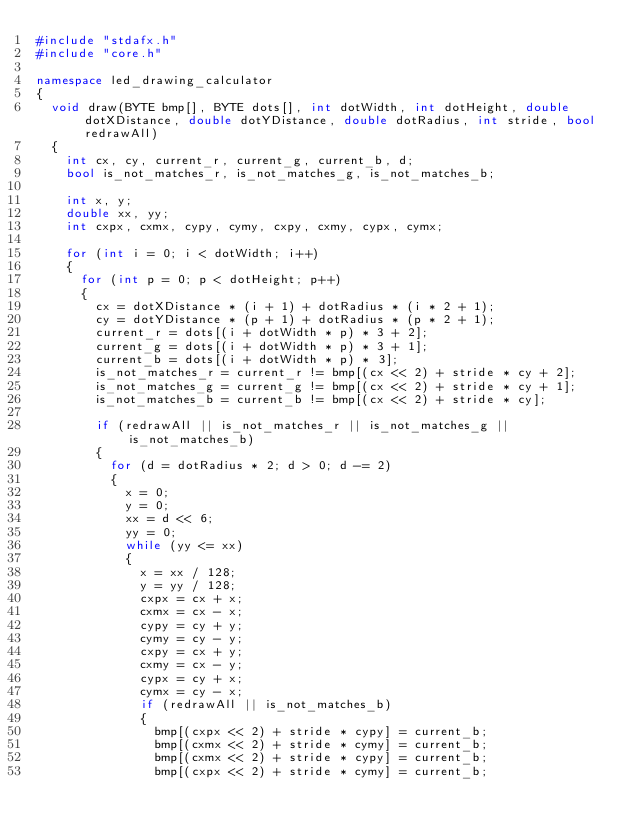<code> <loc_0><loc_0><loc_500><loc_500><_C++_>#include "stdafx.h"
#include "core.h"

namespace led_drawing_calculator
{
	void draw(BYTE bmp[], BYTE dots[], int dotWidth, int dotHeight, double dotXDistance, double dotYDistance, double dotRadius, int stride, bool redrawAll)
	{
		int cx, cy, current_r, current_g, current_b, d;
		bool is_not_matches_r, is_not_matches_g, is_not_matches_b;

		int x, y;
		double xx, yy;
		int cxpx, cxmx, cypy, cymy, cxpy, cxmy, cypx, cymx;

		for (int i = 0; i < dotWidth; i++)
		{
			for (int p = 0; p < dotHeight; p++)
			{
				cx = dotXDistance * (i + 1) + dotRadius * (i * 2 + 1);
				cy = dotYDistance * (p + 1) + dotRadius * (p * 2 + 1);
				current_r = dots[(i + dotWidth * p) * 3 + 2];
				current_g = dots[(i + dotWidth * p) * 3 + 1];
				current_b = dots[(i + dotWidth * p) * 3];
				is_not_matches_r = current_r != bmp[(cx << 2) + stride * cy + 2];
				is_not_matches_g = current_g != bmp[(cx << 2) + stride * cy + 1];
				is_not_matches_b = current_b != bmp[(cx << 2) + stride * cy];

				if (redrawAll || is_not_matches_r || is_not_matches_g || is_not_matches_b)
				{
					for (d = dotRadius * 2; d > 0; d -= 2)
					{
						x = 0;
						y = 0;
						xx = d << 6;
						yy = 0;
						while (yy <= xx)
						{
							x = xx / 128;
							y = yy / 128;
							cxpx = cx + x;
							cxmx = cx - x;
							cypy = cy + y;
							cymy = cy - y;
							cxpy = cx + y;
							cxmy = cx - y;
							cypx = cy + x;
							cymx = cy - x;
							if (redrawAll || is_not_matches_b)
							{
								bmp[(cxpx << 2) + stride * cypy] = current_b;
								bmp[(cxmx << 2) + stride * cymy] = current_b;
								bmp[(cxmx << 2) + stride * cypy] = current_b;
								bmp[(cxpx << 2) + stride * cymy] = current_b;</code> 